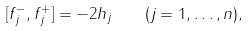<formula> <loc_0><loc_0><loc_500><loc_500>[ f _ { j } ^ { - } , f _ { j } ^ { + } ] = - 2 h _ { j } \quad ( j = 1 , \dots , n ) ,</formula> 